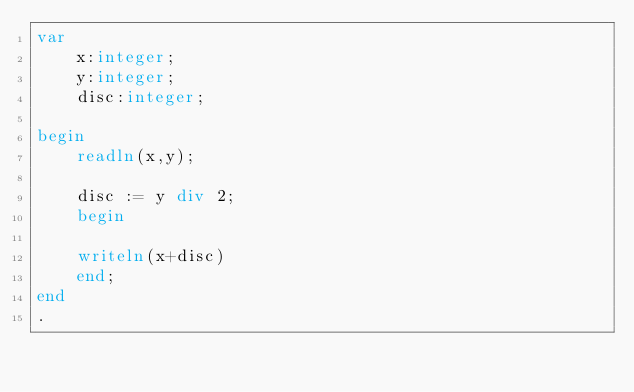<code> <loc_0><loc_0><loc_500><loc_500><_Pascal_>var
    x:integer;
    y:integer;
    disc:integer;
    
begin
    readln(x,y);
    
    disc := y div 2;
    begin
        
    writeln(x+disc)
    end;
end
.</code> 